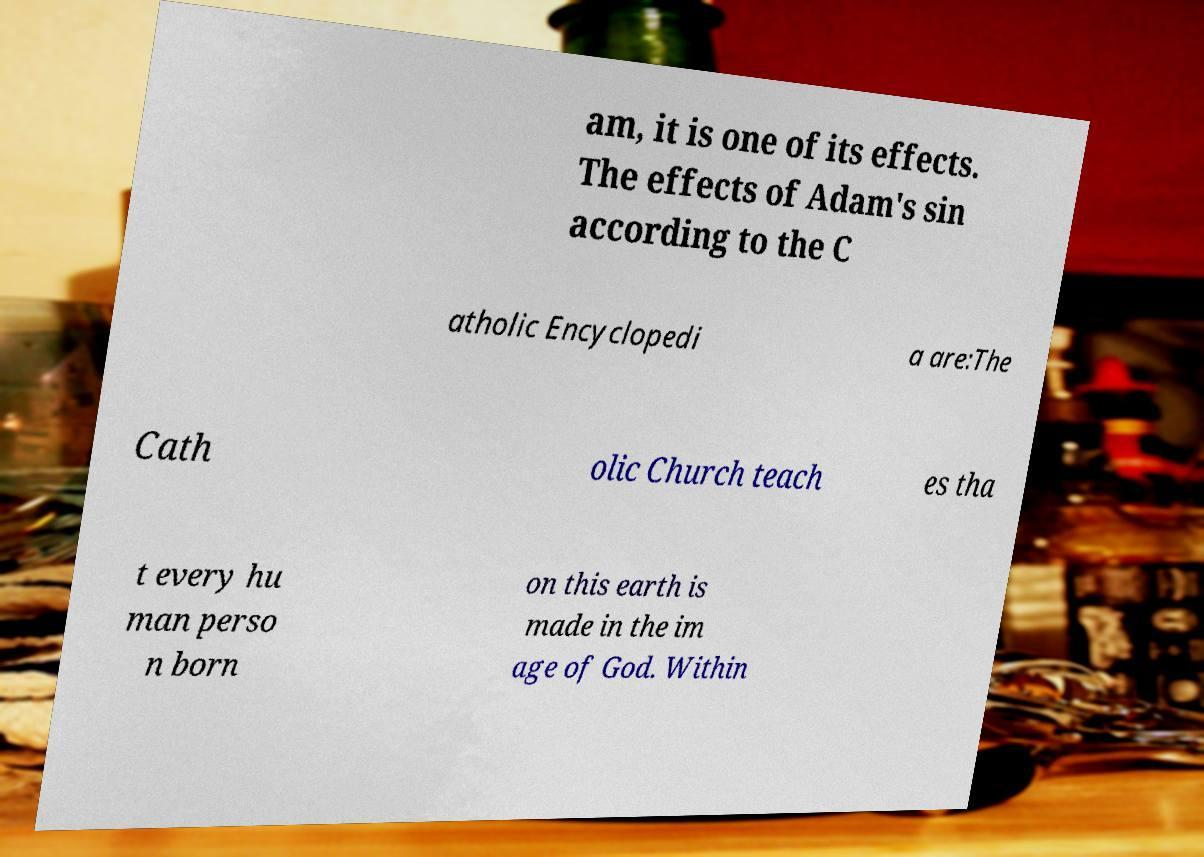Can you accurately transcribe the text from the provided image for me? am, it is one of its effects. The effects of Adam's sin according to the C atholic Encyclopedi a are:The Cath olic Church teach es tha t every hu man perso n born on this earth is made in the im age of God. Within 